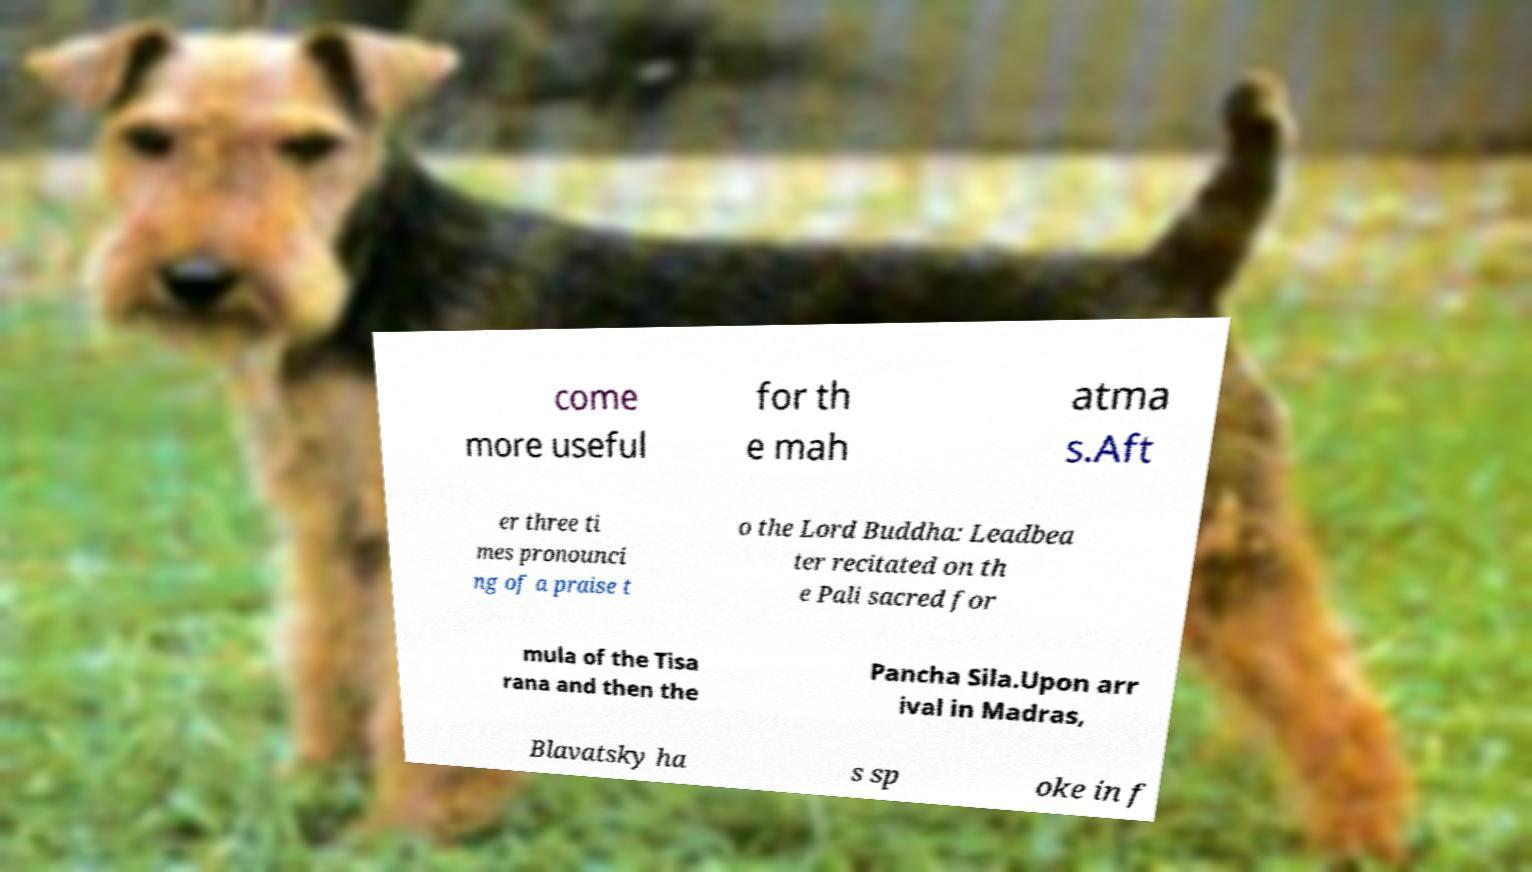Can you accurately transcribe the text from the provided image for me? come more useful for th e mah atma s.Aft er three ti mes pronounci ng of a praise t o the Lord Buddha: Leadbea ter recitated on th e Pali sacred for mula of the Tisa rana and then the Pancha Sila.Upon arr ival in Madras, Blavatsky ha s sp oke in f 